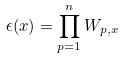<formula> <loc_0><loc_0><loc_500><loc_500>\epsilon ( x ) = \prod _ { p = 1 } ^ { n } W _ { p , x }</formula> 